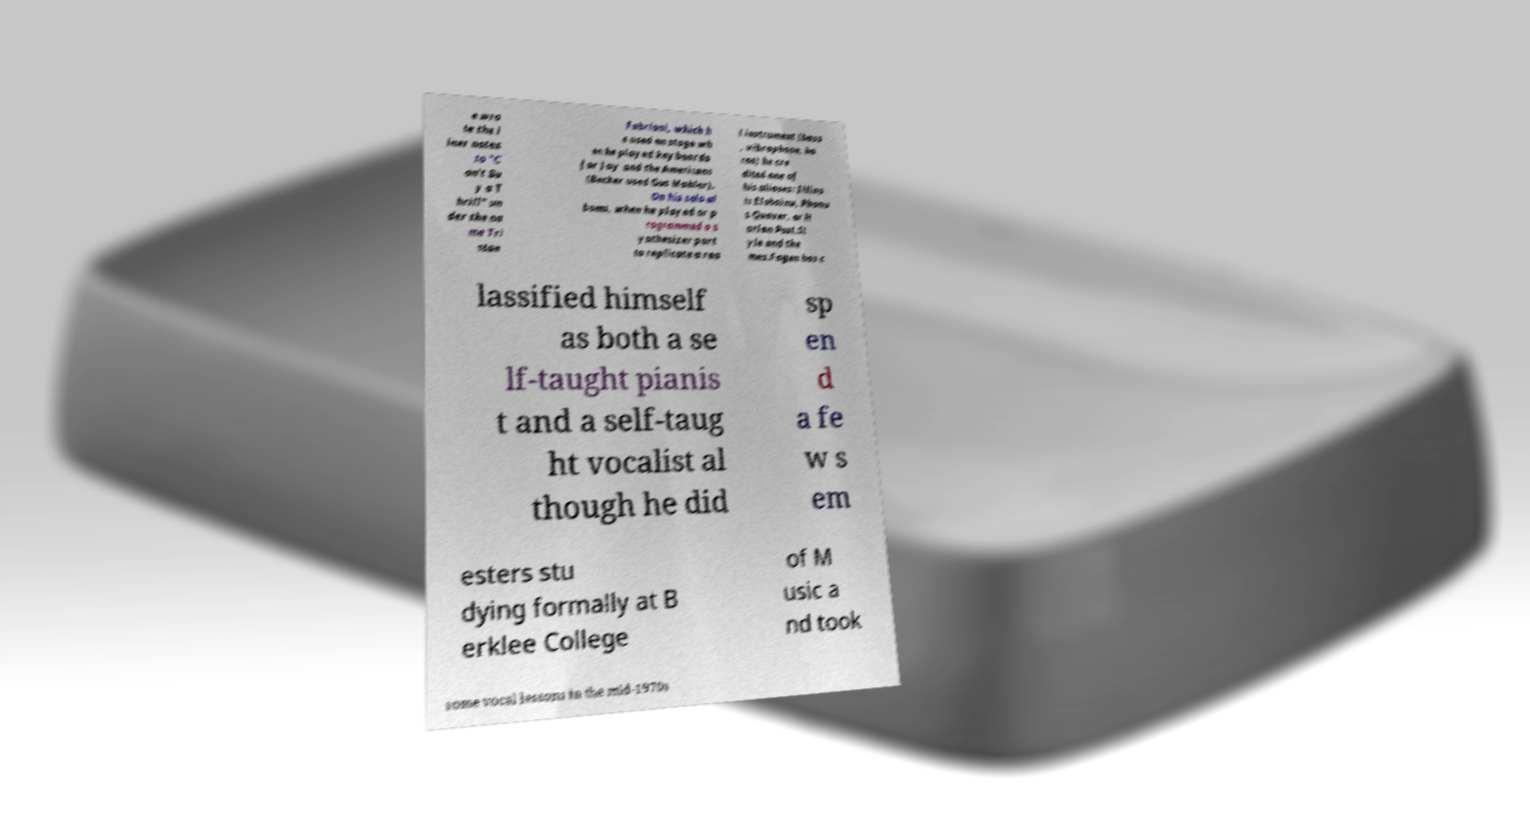For documentation purposes, I need the text within this image transcribed. Could you provide that? e wro te the l iner notes to "C an't Bu y a T hrill" un der the na me Tri stan Fabriani, which h e used on stage wh en he played keyboards for Jay and the Americans (Becker used Gus Mahler). On his solo al bums, when he played or p rogrammed a s ynthesizer part to replicate a rea l instrument (bass , vibraphone, ho rns) he cre dited one of his aliases: Illino is Elohainu, Phonu s Quaver, or H arlan Post.St yle and the mes.Fagen has c lassified himself as both a se lf-taught pianis t and a self-taug ht vocalist al though he did sp en d a fe w s em esters stu dying formally at B erklee College of M usic a nd took some vocal lessons in the mid-1970s 